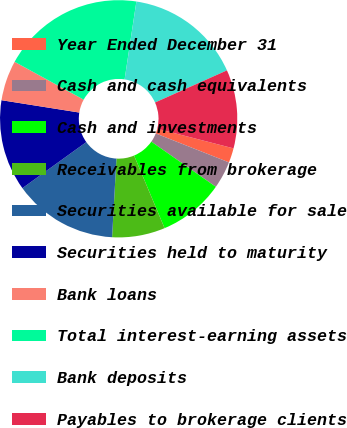<chart> <loc_0><loc_0><loc_500><loc_500><pie_chart><fcel>Year Ended December 31<fcel>Cash and cash equivalents<fcel>Cash and investments<fcel>Receivables from brokerage<fcel>Securities available for sale<fcel>Securities held to maturity<fcel>Bank loans<fcel>Total interest-earning assets<fcel>Bank deposits<fcel>Payables to brokerage clients<nl><fcel>1.98%<fcel>3.73%<fcel>8.95%<fcel>7.21%<fcel>14.18%<fcel>12.44%<fcel>5.47%<fcel>19.41%<fcel>15.92%<fcel>10.7%<nl></chart> 